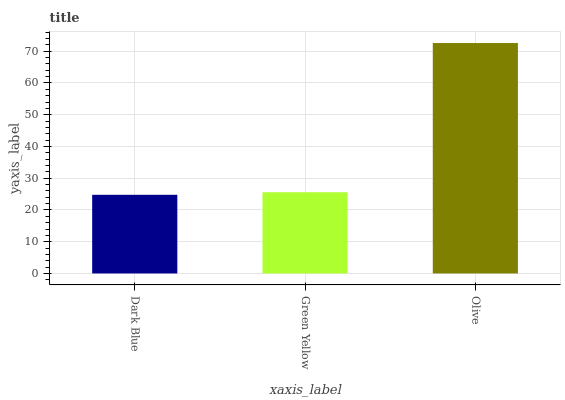Is Dark Blue the minimum?
Answer yes or no. Yes. Is Olive the maximum?
Answer yes or no. Yes. Is Green Yellow the minimum?
Answer yes or no. No. Is Green Yellow the maximum?
Answer yes or no. No. Is Green Yellow greater than Dark Blue?
Answer yes or no. Yes. Is Dark Blue less than Green Yellow?
Answer yes or no. Yes. Is Dark Blue greater than Green Yellow?
Answer yes or no. No. Is Green Yellow less than Dark Blue?
Answer yes or no. No. Is Green Yellow the high median?
Answer yes or no. Yes. Is Green Yellow the low median?
Answer yes or no. Yes. Is Olive the high median?
Answer yes or no. No. Is Dark Blue the low median?
Answer yes or no. No. 